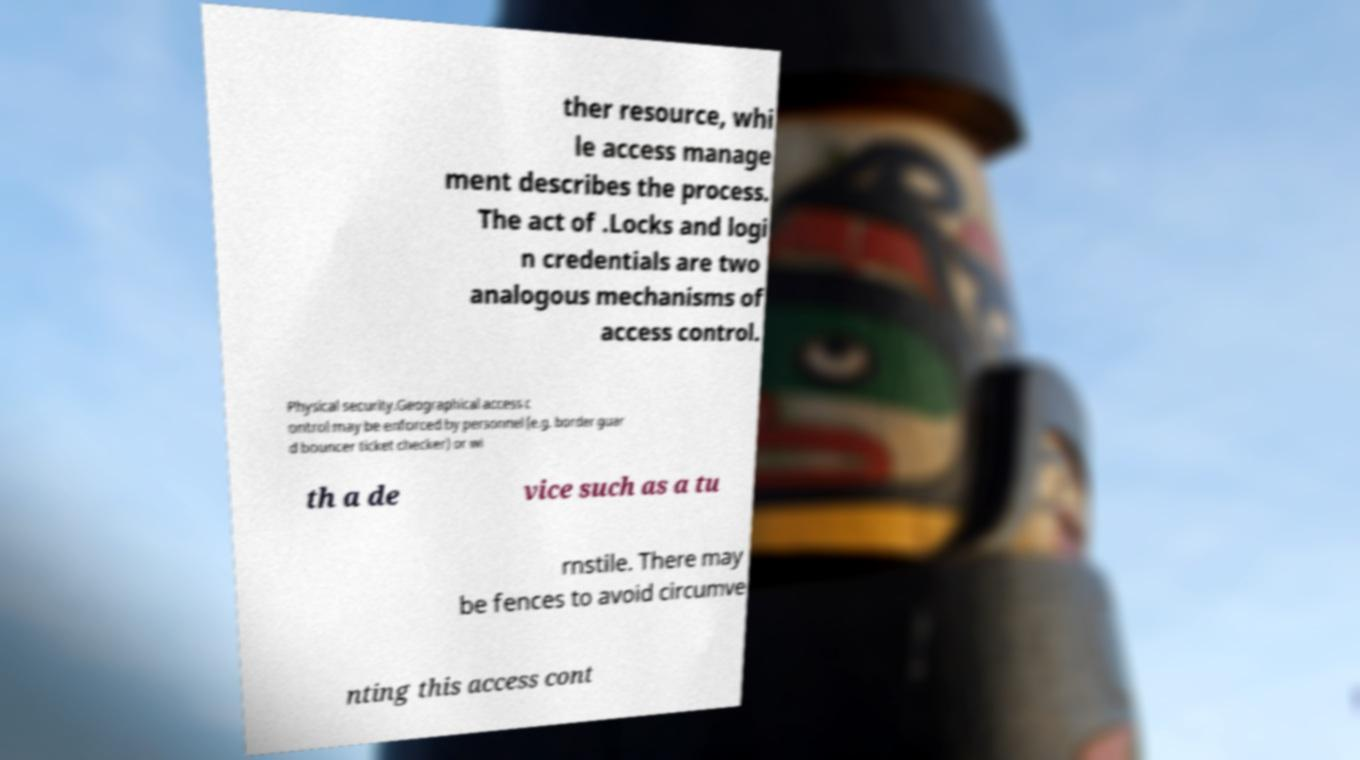Please identify and transcribe the text found in this image. ther resource, whi le access manage ment describes the process. The act of .Locks and logi n credentials are two analogous mechanisms of access control. Physical security.Geographical access c ontrol may be enforced by personnel (e.g. border guar d bouncer ticket checker) or wi th a de vice such as a tu rnstile. There may be fences to avoid circumve nting this access cont 